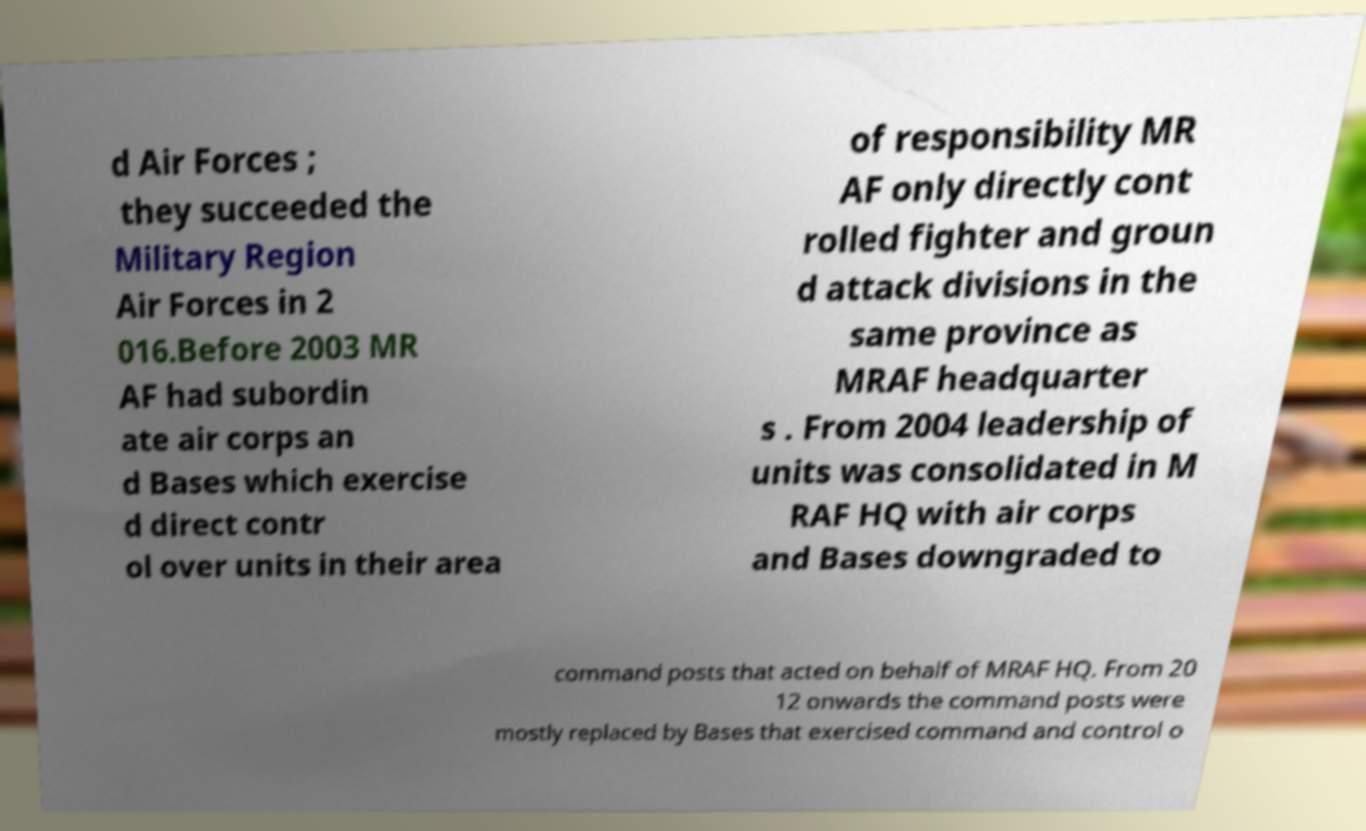Can you read and provide the text displayed in the image?This photo seems to have some interesting text. Can you extract and type it out for me? d Air Forces ; they succeeded the Military Region Air Forces in 2 016.Before 2003 MR AF had subordin ate air corps an d Bases which exercise d direct contr ol over units in their area of responsibility MR AF only directly cont rolled fighter and groun d attack divisions in the same province as MRAF headquarter s . From 2004 leadership of units was consolidated in M RAF HQ with air corps and Bases downgraded to command posts that acted on behalf of MRAF HQ. From 20 12 onwards the command posts were mostly replaced by Bases that exercised command and control o 